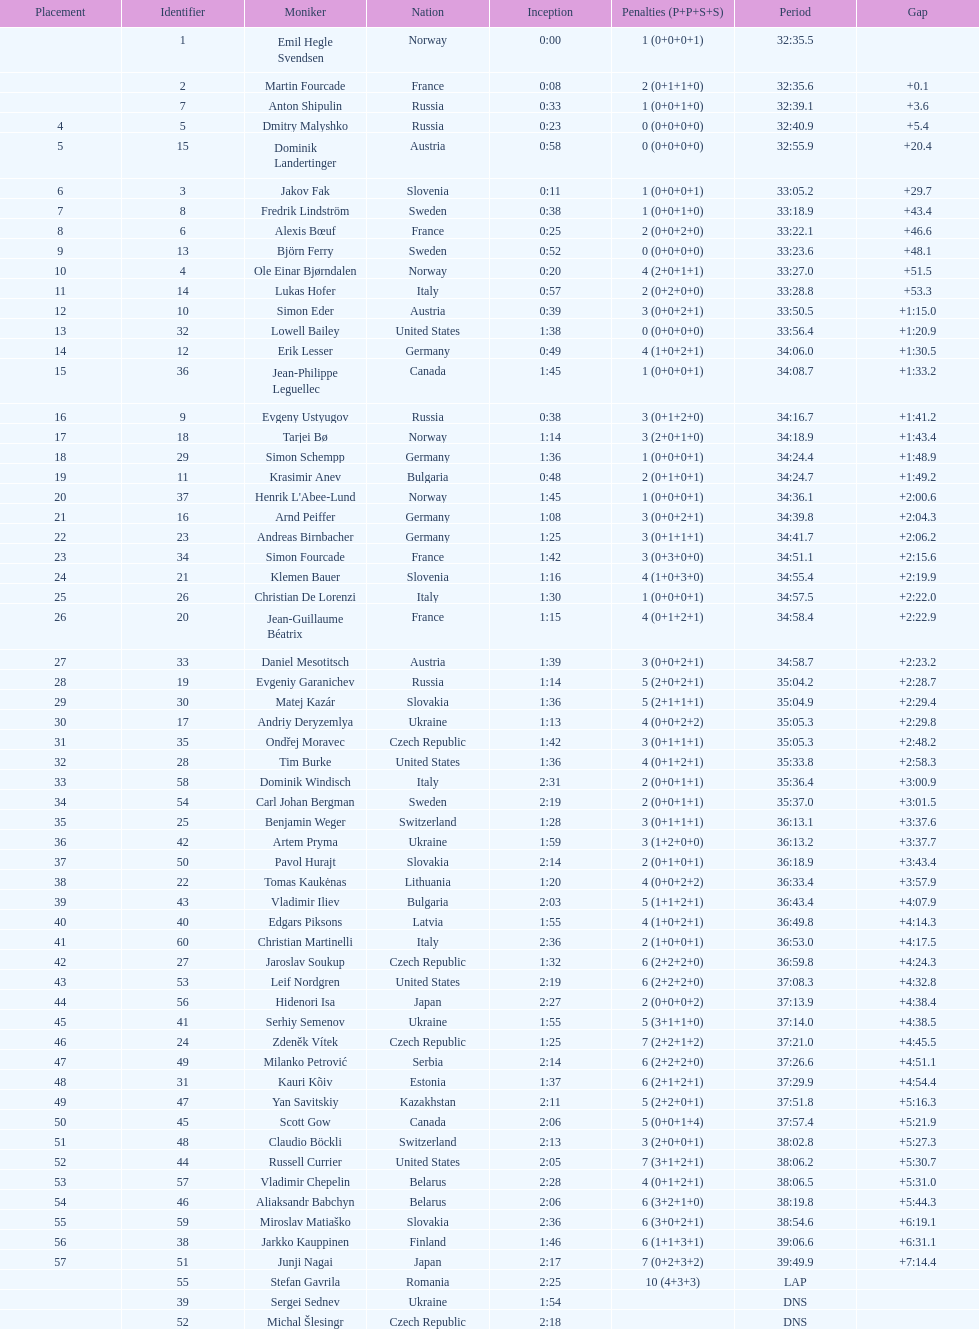Could you parse the entire table? {'header': ['Placement', 'Identifier', 'Moniker', 'Nation', 'Inception', 'Penalties (P+P+S+S)', 'Period', 'Gap'], 'rows': [['', '1', 'Emil Hegle Svendsen', 'Norway', '0:00', '1 (0+0+0+1)', '32:35.5', ''], ['', '2', 'Martin Fourcade', 'France', '0:08', '2 (0+1+1+0)', '32:35.6', '+0.1'], ['', '7', 'Anton Shipulin', 'Russia', '0:33', '1 (0+0+1+0)', '32:39.1', '+3.6'], ['4', '5', 'Dmitry Malyshko', 'Russia', '0:23', '0 (0+0+0+0)', '32:40.9', '+5.4'], ['5', '15', 'Dominik Landertinger', 'Austria', '0:58', '0 (0+0+0+0)', '32:55.9', '+20.4'], ['6', '3', 'Jakov Fak', 'Slovenia', '0:11', '1 (0+0+0+1)', '33:05.2', '+29.7'], ['7', '8', 'Fredrik Lindström', 'Sweden', '0:38', '1 (0+0+1+0)', '33:18.9', '+43.4'], ['8', '6', 'Alexis Bœuf', 'France', '0:25', '2 (0+0+2+0)', '33:22.1', '+46.6'], ['9', '13', 'Björn Ferry', 'Sweden', '0:52', '0 (0+0+0+0)', '33:23.6', '+48.1'], ['10', '4', 'Ole Einar Bjørndalen', 'Norway', '0:20', '4 (2+0+1+1)', '33:27.0', '+51.5'], ['11', '14', 'Lukas Hofer', 'Italy', '0:57', '2 (0+2+0+0)', '33:28.8', '+53.3'], ['12', '10', 'Simon Eder', 'Austria', '0:39', '3 (0+0+2+1)', '33:50.5', '+1:15.0'], ['13', '32', 'Lowell Bailey', 'United States', '1:38', '0 (0+0+0+0)', '33:56.4', '+1:20.9'], ['14', '12', 'Erik Lesser', 'Germany', '0:49', '4 (1+0+2+1)', '34:06.0', '+1:30.5'], ['15', '36', 'Jean-Philippe Leguellec', 'Canada', '1:45', '1 (0+0+0+1)', '34:08.7', '+1:33.2'], ['16', '9', 'Evgeny Ustyugov', 'Russia', '0:38', '3 (0+1+2+0)', '34:16.7', '+1:41.2'], ['17', '18', 'Tarjei Bø', 'Norway', '1:14', '3 (2+0+1+0)', '34:18.9', '+1:43.4'], ['18', '29', 'Simon Schempp', 'Germany', '1:36', '1 (0+0+0+1)', '34:24.4', '+1:48.9'], ['19', '11', 'Krasimir Anev', 'Bulgaria', '0:48', '2 (0+1+0+1)', '34:24.7', '+1:49.2'], ['20', '37', "Henrik L'Abee-Lund", 'Norway', '1:45', '1 (0+0+0+1)', '34:36.1', '+2:00.6'], ['21', '16', 'Arnd Peiffer', 'Germany', '1:08', '3 (0+0+2+1)', '34:39.8', '+2:04.3'], ['22', '23', 'Andreas Birnbacher', 'Germany', '1:25', '3 (0+1+1+1)', '34:41.7', '+2:06.2'], ['23', '34', 'Simon Fourcade', 'France', '1:42', '3 (0+3+0+0)', '34:51.1', '+2:15.6'], ['24', '21', 'Klemen Bauer', 'Slovenia', '1:16', '4 (1+0+3+0)', '34:55.4', '+2:19.9'], ['25', '26', 'Christian De Lorenzi', 'Italy', '1:30', '1 (0+0+0+1)', '34:57.5', '+2:22.0'], ['26', '20', 'Jean-Guillaume Béatrix', 'France', '1:15', '4 (0+1+2+1)', '34:58.4', '+2:22.9'], ['27', '33', 'Daniel Mesotitsch', 'Austria', '1:39', '3 (0+0+2+1)', '34:58.7', '+2:23.2'], ['28', '19', 'Evgeniy Garanichev', 'Russia', '1:14', '5 (2+0+2+1)', '35:04.2', '+2:28.7'], ['29', '30', 'Matej Kazár', 'Slovakia', '1:36', '5 (2+1+1+1)', '35:04.9', '+2:29.4'], ['30', '17', 'Andriy Deryzemlya', 'Ukraine', '1:13', '4 (0+0+2+2)', '35:05.3', '+2:29.8'], ['31', '35', 'Ondřej Moravec', 'Czech Republic', '1:42', '3 (0+1+1+1)', '35:05.3', '+2:48.2'], ['32', '28', 'Tim Burke', 'United States', '1:36', '4 (0+1+2+1)', '35:33.8', '+2:58.3'], ['33', '58', 'Dominik Windisch', 'Italy', '2:31', '2 (0+0+1+1)', '35:36.4', '+3:00.9'], ['34', '54', 'Carl Johan Bergman', 'Sweden', '2:19', '2 (0+0+1+1)', '35:37.0', '+3:01.5'], ['35', '25', 'Benjamin Weger', 'Switzerland', '1:28', '3 (0+1+1+1)', '36:13.1', '+3:37.6'], ['36', '42', 'Artem Pryma', 'Ukraine', '1:59', '3 (1+2+0+0)', '36:13.2', '+3:37.7'], ['37', '50', 'Pavol Hurajt', 'Slovakia', '2:14', '2 (0+1+0+1)', '36:18.9', '+3:43.4'], ['38', '22', 'Tomas Kaukėnas', 'Lithuania', '1:20', '4 (0+0+2+2)', '36:33.4', '+3:57.9'], ['39', '43', 'Vladimir Iliev', 'Bulgaria', '2:03', '5 (1+1+2+1)', '36:43.4', '+4:07.9'], ['40', '40', 'Edgars Piksons', 'Latvia', '1:55', '4 (1+0+2+1)', '36:49.8', '+4:14.3'], ['41', '60', 'Christian Martinelli', 'Italy', '2:36', '2 (1+0+0+1)', '36:53.0', '+4:17.5'], ['42', '27', 'Jaroslav Soukup', 'Czech Republic', '1:32', '6 (2+2+2+0)', '36:59.8', '+4:24.3'], ['43', '53', 'Leif Nordgren', 'United States', '2:19', '6 (2+2+2+0)', '37:08.3', '+4:32.8'], ['44', '56', 'Hidenori Isa', 'Japan', '2:27', '2 (0+0+0+2)', '37:13.9', '+4:38.4'], ['45', '41', 'Serhiy Semenov', 'Ukraine', '1:55', '5 (3+1+1+0)', '37:14.0', '+4:38.5'], ['46', '24', 'Zdeněk Vítek', 'Czech Republic', '1:25', '7 (2+2+1+2)', '37:21.0', '+4:45.5'], ['47', '49', 'Milanko Petrović', 'Serbia', '2:14', '6 (2+2+2+0)', '37:26.6', '+4:51.1'], ['48', '31', 'Kauri Kõiv', 'Estonia', '1:37', '6 (2+1+2+1)', '37:29.9', '+4:54.4'], ['49', '47', 'Yan Savitskiy', 'Kazakhstan', '2:11', '5 (2+2+0+1)', '37:51.8', '+5:16.3'], ['50', '45', 'Scott Gow', 'Canada', '2:06', '5 (0+0+1+4)', '37:57.4', '+5:21.9'], ['51', '48', 'Claudio Böckli', 'Switzerland', '2:13', '3 (2+0+0+1)', '38:02.8', '+5:27.3'], ['52', '44', 'Russell Currier', 'United States', '2:05', '7 (3+1+2+1)', '38:06.2', '+5:30.7'], ['53', '57', 'Vladimir Chepelin', 'Belarus', '2:28', '4 (0+1+2+1)', '38:06.5', '+5:31.0'], ['54', '46', 'Aliaksandr Babchyn', 'Belarus', '2:06', '6 (3+2+1+0)', '38:19.8', '+5:44.3'], ['55', '59', 'Miroslav Matiaško', 'Slovakia', '2:36', '6 (3+0+2+1)', '38:54.6', '+6:19.1'], ['56', '38', 'Jarkko Kauppinen', 'Finland', '1:46', '6 (1+1+3+1)', '39:06.6', '+6:31.1'], ['57', '51', 'Junji Nagai', 'Japan', '2:17', '7 (0+2+3+2)', '39:49.9', '+7:14.4'], ['', '55', 'Stefan Gavrila', 'Romania', '2:25', '10 (4+3+3)', 'LAP', ''], ['', '39', 'Sergei Sednev', 'Ukraine', '1:54', '', 'DNS', ''], ['', '52', 'Michal Šlesingr', 'Czech Republic', '2:18', '', 'DNS', '']]} How many united states competitors did not win medals? 4. 